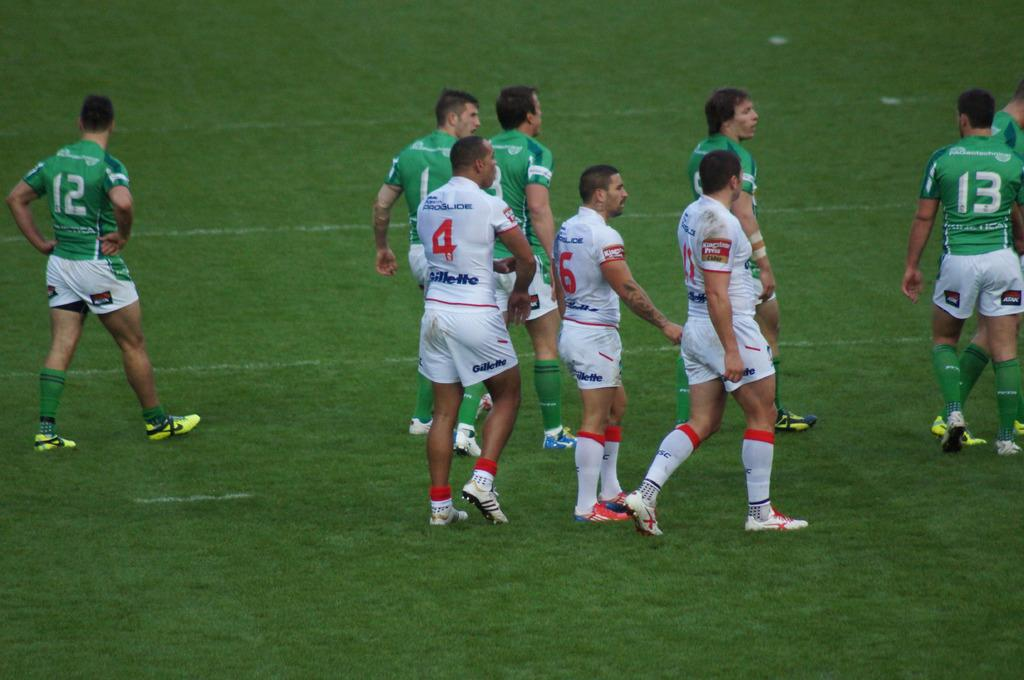What are the persons in the image doing? The persons in the image are walking. What type of footwear are the persons wearing? The persons are wearing shoes. What type of clothing is covering their feet? The persons are wearing socks. What type of clothing is covering their bodies? The persons are wearing dresses. What can be seen in the background of the image? There is ground visible in the background of the image. What type of dinner is being served in the image? There is no dinner present in the image; it features persons walking. What is the temper of the persons in the image? The image does not provide information about the temper of the persons; it only shows them walking. 